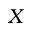<formula> <loc_0><loc_0><loc_500><loc_500>X</formula> 